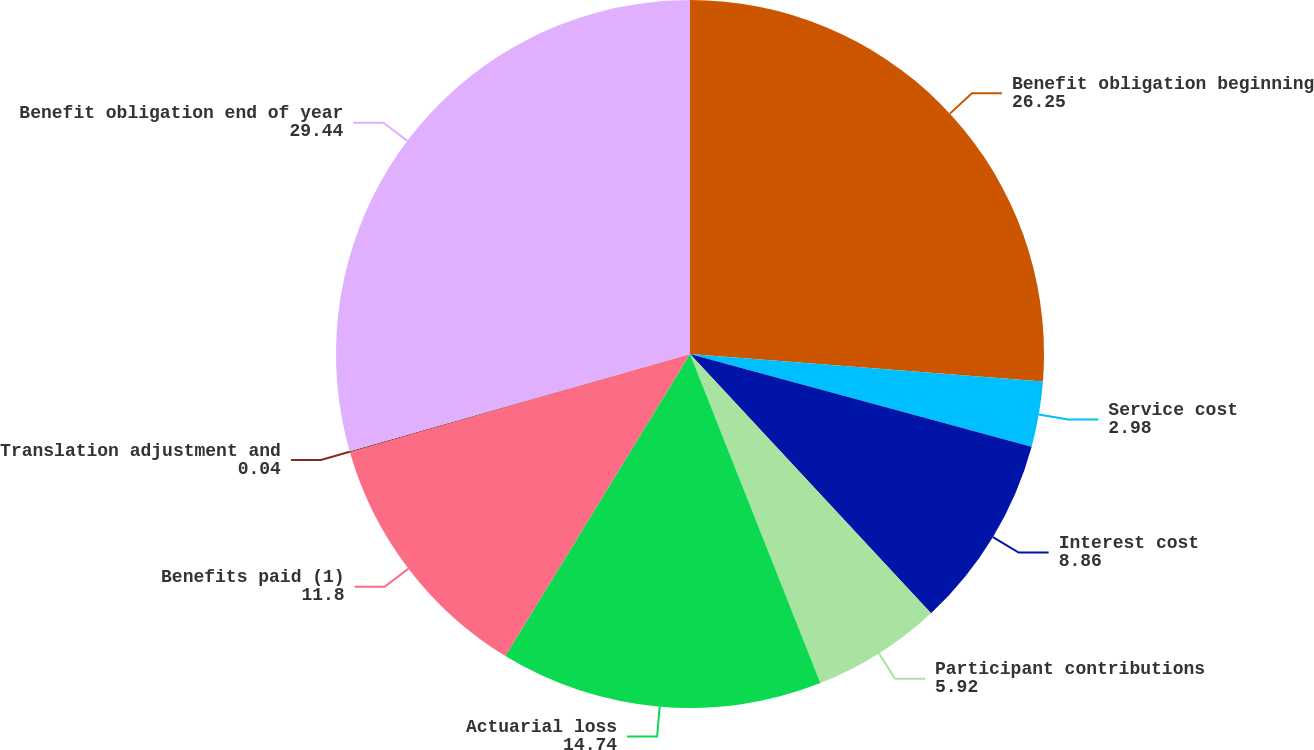Convert chart. <chart><loc_0><loc_0><loc_500><loc_500><pie_chart><fcel>Benefit obligation beginning<fcel>Service cost<fcel>Interest cost<fcel>Participant contributions<fcel>Actuarial loss<fcel>Benefits paid (1)<fcel>Translation adjustment and<fcel>Benefit obligation end of year<nl><fcel>26.25%<fcel>2.98%<fcel>8.86%<fcel>5.92%<fcel>14.74%<fcel>11.8%<fcel>0.04%<fcel>29.44%<nl></chart> 